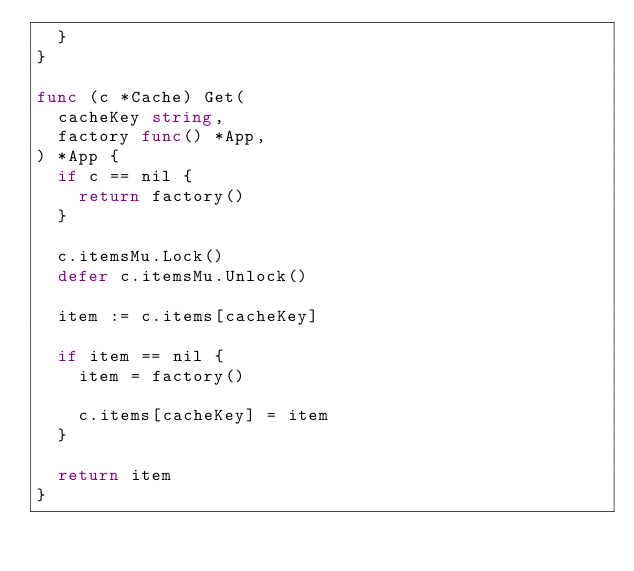<code> <loc_0><loc_0><loc_500><loc_500><_Go_>	}
}

func (c *Cache) Get(
	cacheKey string,
	factory func() *App,
) *App {
	if c == nil {
		return factory()
	}

	c.itemsMu.Lock()
	defer c.itemsMu.Unlock()

	item := c.items[cacheKey]

	if item == nil {
		item = factory()

		c.items[cacheKey] = item
	}

	return item
}
</code> 